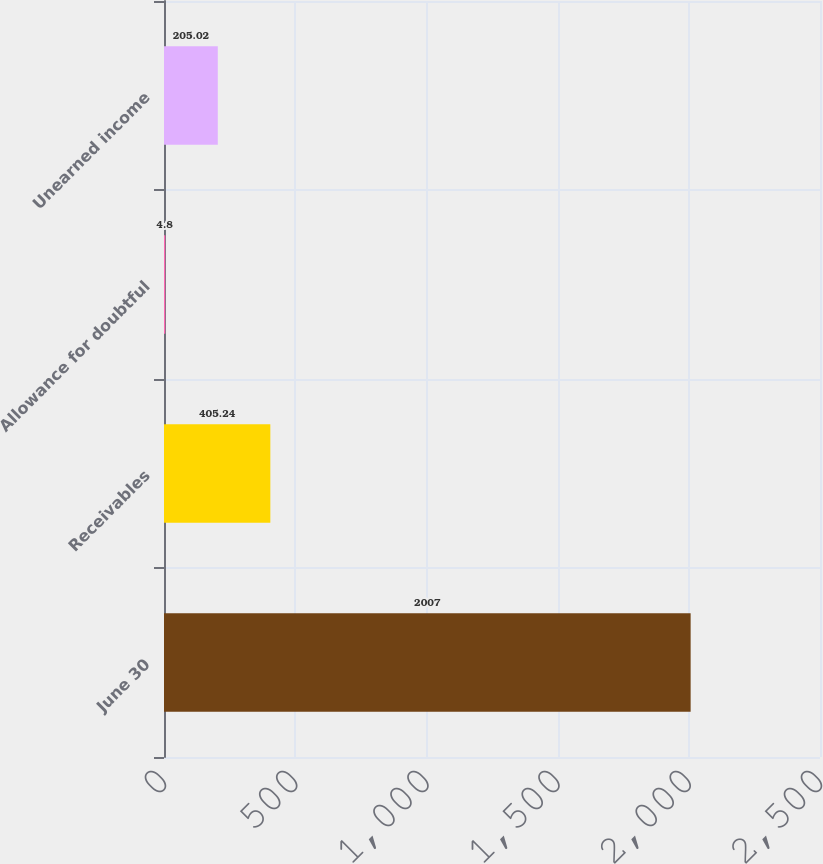Convert chart. <chart><loc_0><loc_0><loc_500><loc_500><bar_chart><fcel>June 30<fcel>Receivables<fcel>Allowance for doubtful<fcel>Unearned income<nl><fcel>2007<fcel>405.24<fcel>4.8<fcel>205.02<nl></chart> 